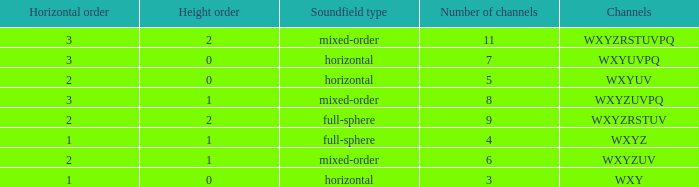If the channels is wxyzrstuvpq, what is the horizontal order? 3.0. 